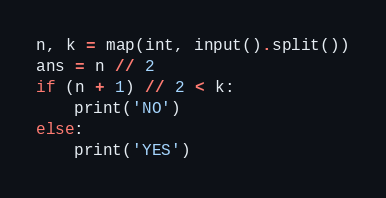<code> <loc_0><loc_0><loc_500><loc_500><_Python_>n, k = map(int, input().split())
ans = n // 2
if (n + 1) // 2 < k:
    print('NO')
else:
    print('YES')</code> 